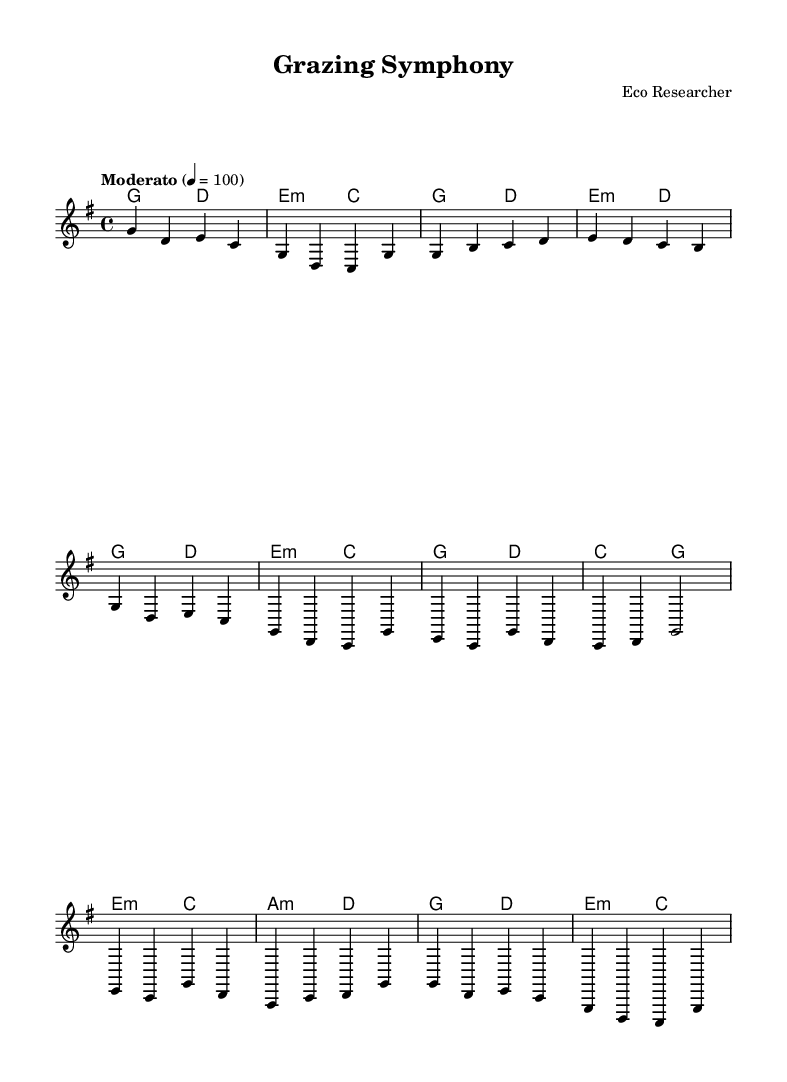What is the key signature of this music? The key signature is G major, indicated by one sharp (F#) on the staff.
Answer: G major What is the time signature of this piece? The time signature is indicated at the beginning of the score as 4/4, meaning there are four beats in each measure.
Answer: 4/4 What is the tempo marking for this piece? The tempo marking is specified as "Moderato," followed by the setting of a quarter note equals 100 beats per minute, indicating moderate speed.
Answer: Moderato How many measures are in the chorus section? By analyzing the score, the chorus section consists of four measures, each contributing to the thematic repetition typical in folk music.
Answer: 4 What is the harmonic progression used in the intro? The harmonic progression in the intro consists of two chords: G major followed by D major. These chords set the tonal foundation for the piece.
Answer: G - D What is the key feature of the bridge in this composition? The bridge introduces a different progression with a transition from E minor to C major, providing a contrast to the previous sections and enhancing emotional dynamism typical of folk music.
Answer: E minor - C What thematic element does the phrase "Grazing Symphony" suggest? The title "Grazing Symphony" suggests an appreciation for nature and wildlife, likely reflecting the ecological theme of the song, which celebrates biodiversity and its importance in ecosystems.
Answer: Biodiversity 